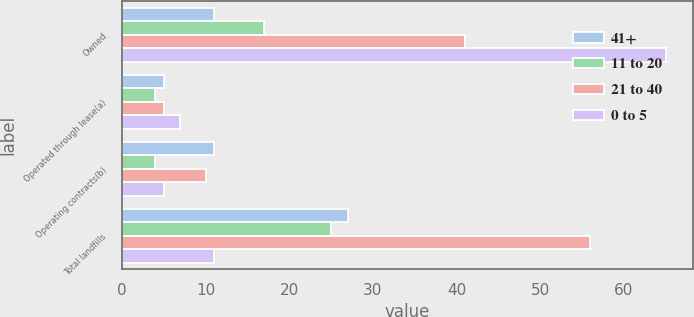Convert chart. <chart><loc_0><loc_0><loc_500><loc_500><stacked_bar_chart><ecel><fcel>Owned<fcel>Operated through lease(a)<fcel>Operating contracts(b)<fcel>Total landfills<nl><fcel>41+<fcel>11<fcel>5<fcel>11<fcel>27<nl><fcel>11 to 20<fcel>17<fcel>4<fcel>4<fcel>25<nl><fcel>21 to 40<fcel>41<fcel>5<fcel>10<fcel>56<nl><fcel>0 to 5<fcel>65<fcel>7<fcel>5<fcel>11<nl></chart> 